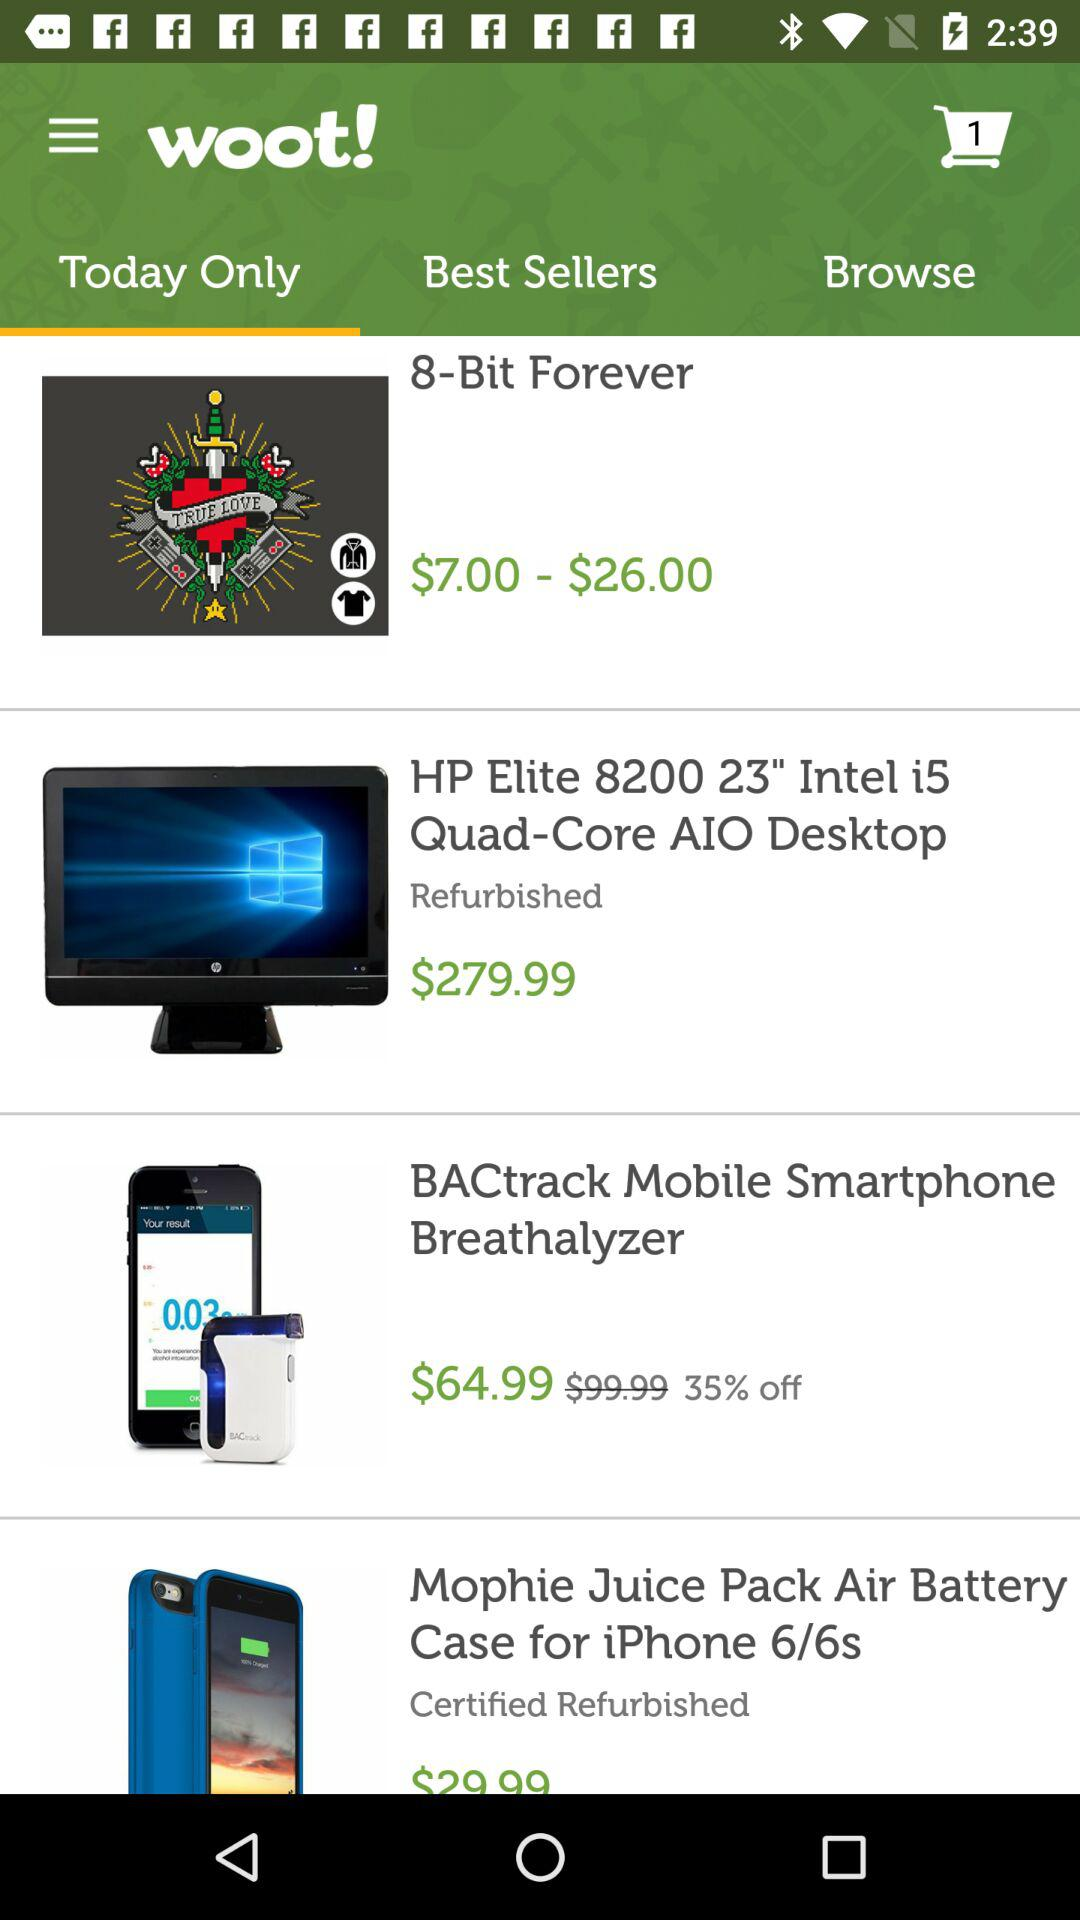Which tab is selected? The selected tab is "Today Only". 